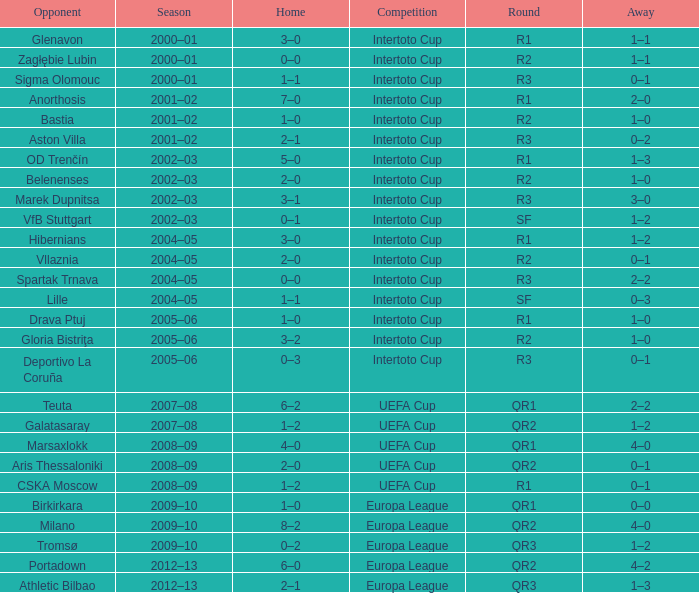What is the home score with marek dupnitsa as opponent? 3–1. 